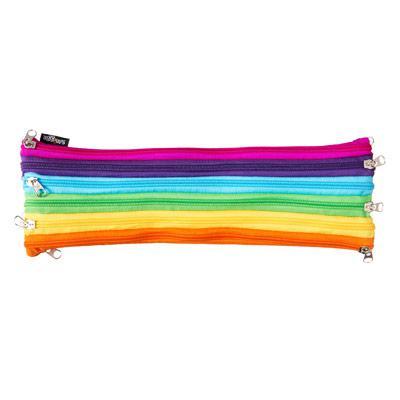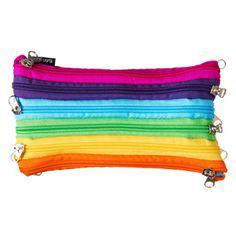The first image is the image on the left, the second image is the image on the right. For the images shown, is this caption "The pair of images contain nearly identical items, with the same colors." true? Answer yes or no. Yes. 